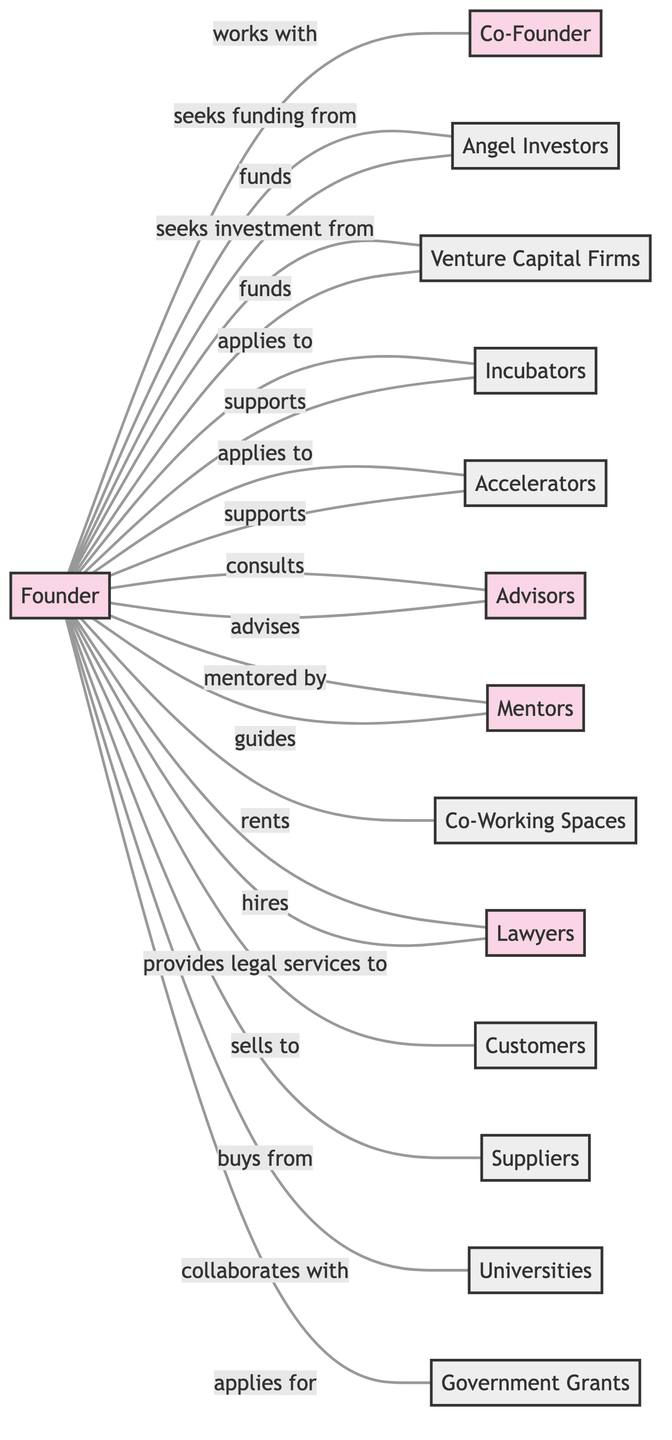What is the label for the node that represents the visionary entrepreneur leading the startup? The node description for the "Founder" indicates that this person is the visionary entrepreneur leading the startup.
Answer: Founder How many entities are in the diagram? By counting the nodes categorized as entities, we find that there are a total of 9 entities.
Answer: 9 Who provides legal services to the founder? The diagram shows a direct relationship from "Lawyers" to "Founder" with the label "provides legal services to," indicating that lawyers are responsible for this service.
Answer: Lawyers What is the relationship between the founder and customers? The diagram indicates that the founder "sells to" customers, establishing a direct sales relationship.
Answer: sells to Which entity supports the founder and is known for offering mentorship? The diagram identifies incubators as supporting entities while also highlighting that these organizations provide mentorship and resources directly to the founder.
Answer: Incubators What type of professionals does the founder consult? The diagram specifies that the founder consults advisors, who are experienced professionals providing guidance.
Answer: Advisors Which program provides intensive support and funding for early-stage startups? The relationships in the diagram point towards accelerators as the programs designed to provide intensive support and funding.
Answer: Accelerators How does the founder interact with suppliers? The diagram shows that the founder "buys from" suppliers, indicating a procurement relationship for necessary resources.
Answer: buys from Who are the seasoned entrepreneurs that provide personal guidance to the founder? The diagram describes mentors as the seasoned entrepreneurs providing personal guidance, indicating the relationship between the founder and this group.
Answer: Mentors 